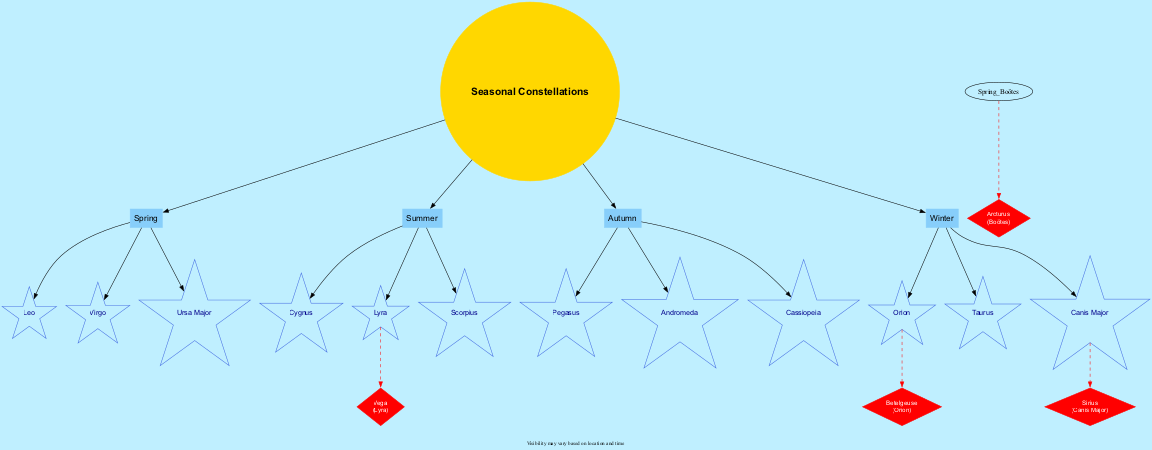What are the three constellations in Summer? The diagram lists the constellations under the Summer season. They are Cygnus, Lyra, and Scorpius.
Answer: Cygnus, Lyra, Scorpius Which season includes the constellation Orion? By looking at the Winter season section in the diagram, Orion is listed as one of its constellations.
Answer: Winter How many key stars are identified in the diagram? The diagram shows four key stars: Sirius, Vega, Betelgeuse, and Arcturus. Thus, counting these entries gives us a total of four key stars.
Answer: Four Which key star is associated with the constellation Canis Major? Checking the key stars mentioned in the diagram, Sirius is the star linked to Canis Major.
Answer: Sirius What color represents the seasonal constellations? The diagram indicates that the seasonal constellation nodes are colored lightskyblue, according to their design in the graph.
Answer: lightskyblue What is the relationship between the constellation Lyra and the star Vega? The diagram indicates that Vega is connected to the constellation Lyra, specifically in the Summer season, through a dashed edge line which shows that Vega is a key star within the Lyra constellation.
Answer: Vega is in Lyra Which constellation is linked to the key star Betelgeuse? The diagram specifies that Betelgeuse is linked to the constellation Orion, as shown by the connection in the Winter season.
Answer: Orion Which season features the constellation Pegasus? According to the seasonal listing in the diagram, Pegasus is mentioned under the Autumn season.
Answer: Autumn What is the note regarding visibility in the diagram? The diagram includes a note stating that "Visibility may vary based on location and time," emphasizing that the visibility of constellations and stars differs with varying conditions.
Answer: Visibility may vary based on location and time 